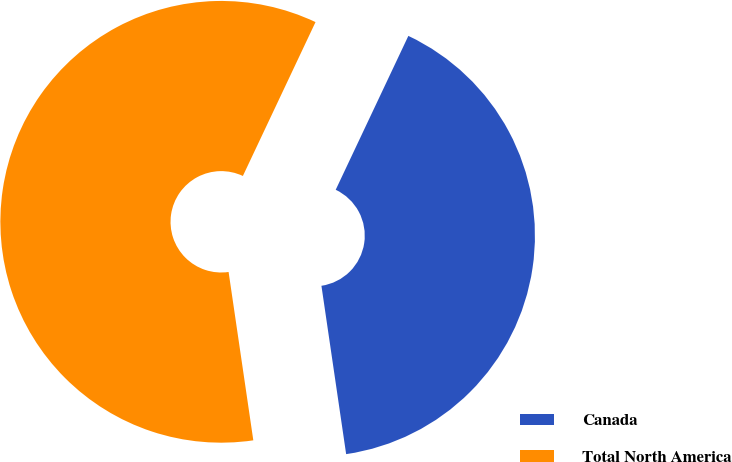Convert chart. <chart><loc_0><loc_0><loc_500><loc_500><pie_chart><fcel>Canada<fcel>Total North America<nl><fcel>40.66%<fcel>59.34%<nl></chart> 